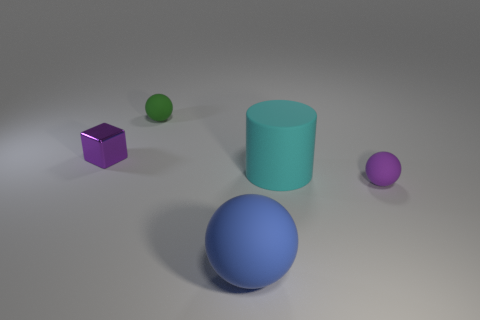There is a rubber thing that is the same color as the metallic object; what is its size?
Make the answer very short. Small. There is a purple thing behind the large cylinder; what material is it?
Your answer should be very brief. Metal. What is the blue object made of?
Ensure brevity in your answer.  Rubber. Are the purple object that is right of the tiny purple cube and the tiny green ball made of the same material?
Provide a short and direct response. Yes. Are there fewer tiny green things that are behind the big cylinder than large matte balls?
Your answer should be very brief. No. The shiny cube that is the same size as the purple sphere is what color?
Your answer should be very brief. Purple. How many tiny green rubber objects are the same shape as the large blue rubber object?
Offer a terse response. 1. The large object behind the large blue rubber object is what color?
Keep it short and to the point. Cyan. What number of matte objects are either yellow things or purple blocks?
Offer a terse response. 0. There is a matte object that is the same color as the metallic cube; what shape is it?
Give a very brief answer. Sphere. 